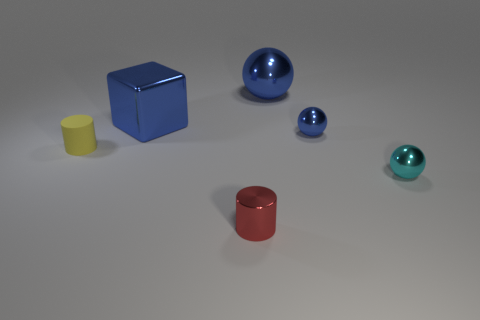Can you tell me what shapes are present in the image? Certainly! In the image, there are a variety of geometric shapes, including a cube, a large sphere, a small sphere, a cylinder, and a smaller rounded object that appears to be a smaller cylinder or a truncated cone. 